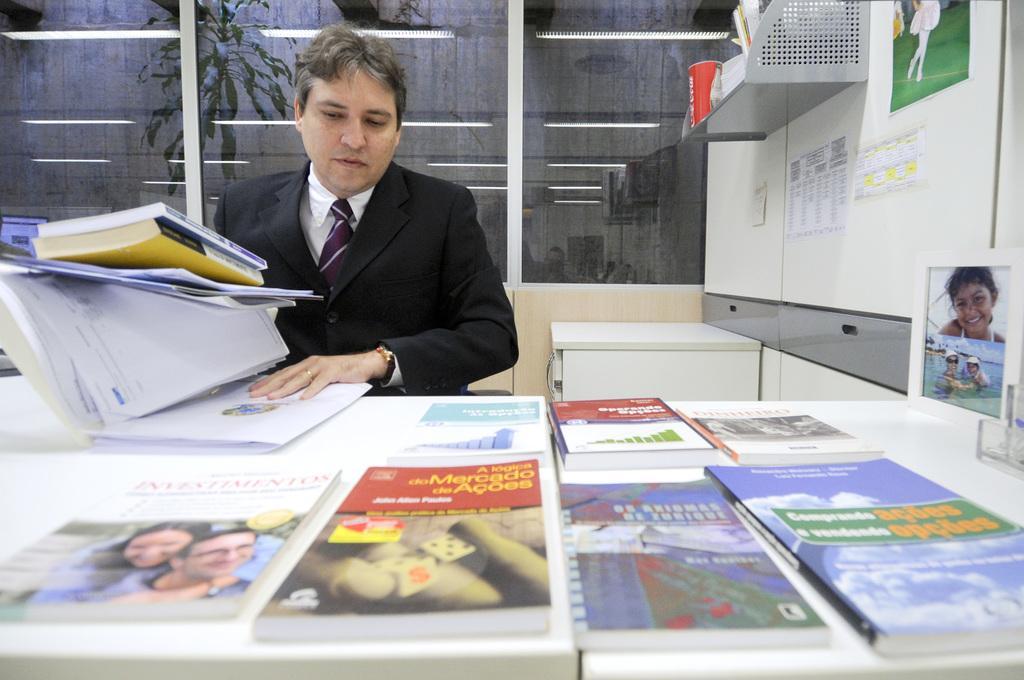Can you describe this image briefly? In this image we can see a man is sitting at the table and holding books and papers in his hands and on the table there are books, photo frame and an object. In the background we can see glass doors, wall, cupboard, objects on a stand and there are papers, poster attached to the wall. We can see reflections of lights, plant and objects on the glass doors. 